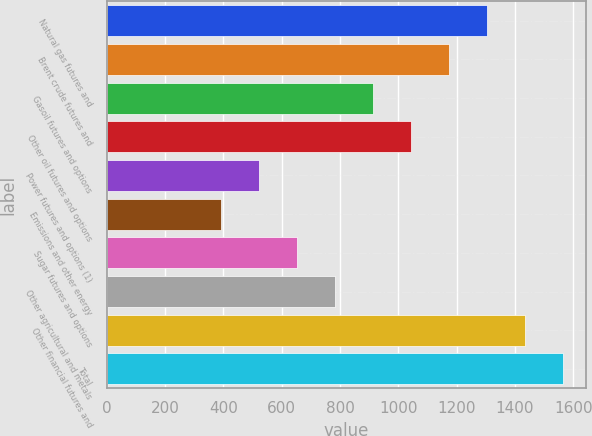Convert chart to OTSL. <chart><loc_0><loc_0><loc_500><loc_500><bar_chart><fcel>Natural gas futures and<fcel>Brent crude futures and<fcel>Gasoil futures and options<fcel>Other oil futures and options<fcel>Power futures and options (1)<fcel>Emissions and other energy<fcel>Sugar futures and options<fcel>Other agricultural and metals<fcel>Other financial futures and<fcel>Total<nl><fcel>1303.01<fcel>1172.77<fcel>912.29<fcel>1042.53<fcel>521.57<fcel>391.33<fcel>651.81<fcel>782.05<fcel>1433.25<fcel>1563.49<nl></chart> 